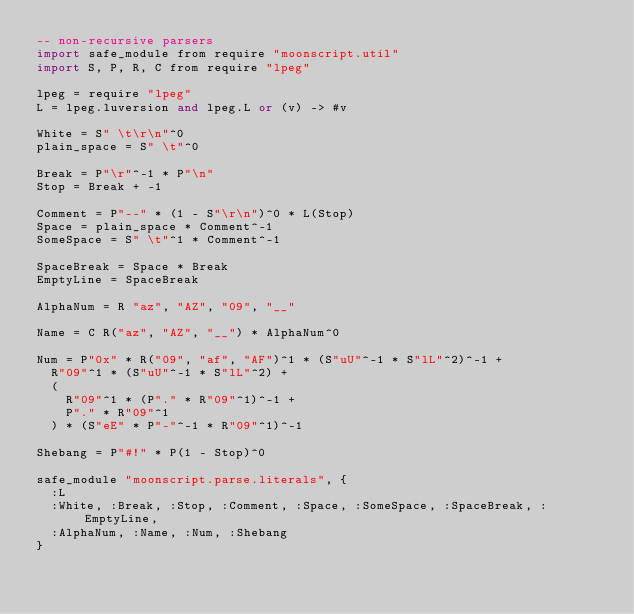<code> <loc_0><loc_0><loc_500><loc_500><_MoonScript_>-- non-recursive parsers
import safe_module from require "moonscript.util"
import S, P, R, C from require "lpeg"

lpeg = require "lpeg"
L = lpeg.luversion and lpeg.L or (v) -> #v

White = S" \t\r\n"^0
plain_space = S" \t"^0

Break = P"\r"^-1 * P"\n"
Stop = Break + -1

Comment = P"--" * (1 - S"\r\n")^0 * L(Stop)
Space = plain_space * Comment^-1
SomeSpace = S" \t"^1 * Comment^-1

SpaceBreak = Space * Break
EmptyLine = SpaceBreak

AlphaNum = R "az", "AZ", "09", "__"

Name = C R("az", "AZ", "__") * AlphaNum^0

Num = P"0x" * R("09", "af", "AF")^1 * (S"uU"^-1 * S"lL"^2)^-1 +
  R"09"^1 * (S"uU"^-1 * S"lL"^2) +
  (
    R"09"^1 * (P"." * R"09"^1)^-1 +
    P"." * R"09"^1
  ) * (S"eE" * P"-"^-1 * R"09"^1)^-1

Shebang = P"#!" * P(1 - Stop)^0

safe_module "moonscript.parse.literals", {
  :L
  :White, :Break, :Stop, :Comment, :Space, :SomeSpace, :SpaceBreak, :EmptyLine,
  :AlphaNum, :Name, :Num, :Shebang
}
</code> 